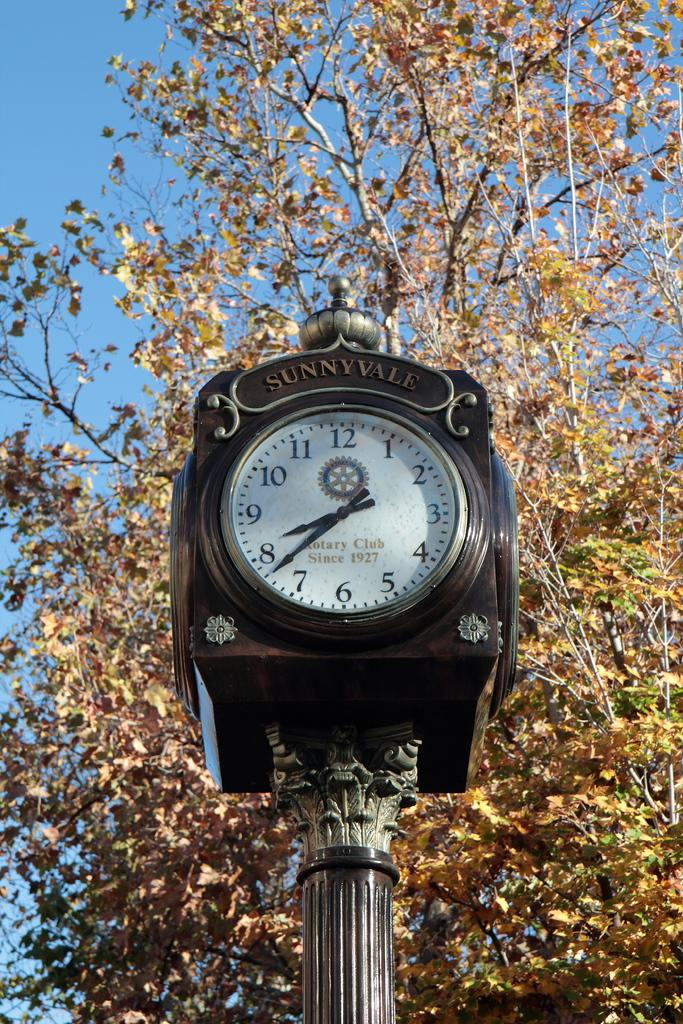<image>
Summarize the visual content of the image. A Rotary Club clock in Sunnyvale is outdoors near a tree. 